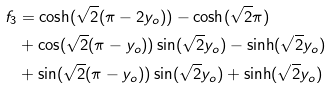<formula> <loc_0><loc_0><loc_500><loc_500>f _ { 3 } & = \cosh ( \sqrt { 2 } ( \pi - 2 y _ { o } ) ) - \cosh ( \sqrt { 2 } \pi ) \\ & + \cos ( \sqrt { 2 } ( \pi - y _ { o } ) ) \sin ( \sqrt { 2 } y _ { o } ) - \sinh ( \sqrt { 2 } y _ { o } ) \\ & + \sin ( \sqrt { 2 } ( \pi - y _ { o } ) ) \sin ( \sqrt { 2 } y _ { o } ) + \sinh ( \sqrt { 2 } y _ { o } )</formula> 